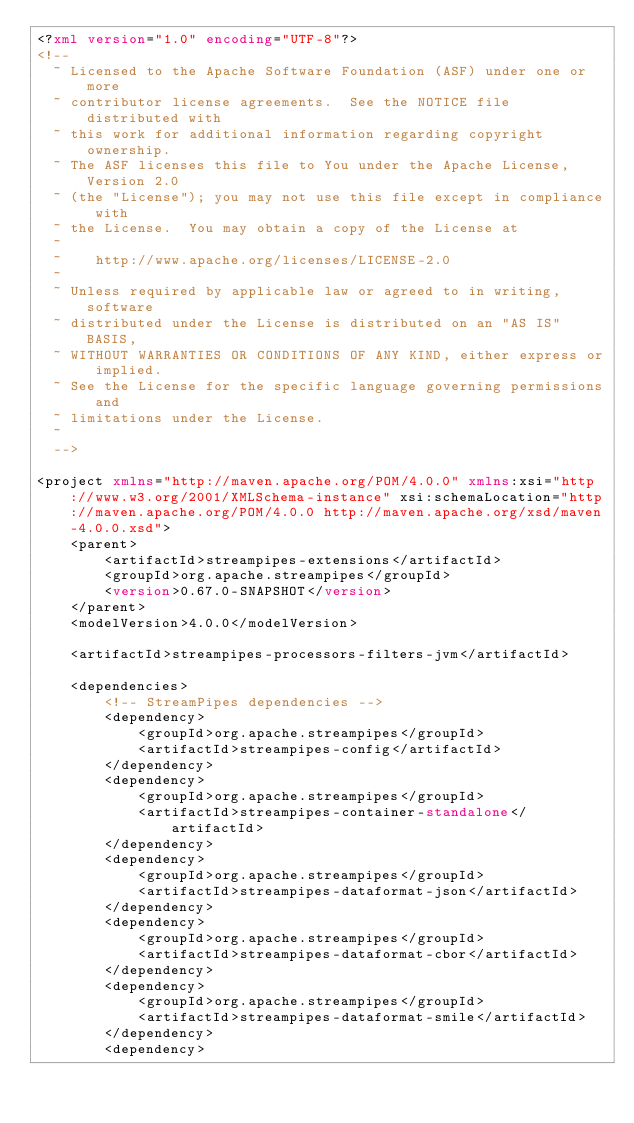<code> <loc_0><loc_0><loc_500><loc_500><_XML_><?xml version="1.0" encoding="UTF-8"?>
<!--
  ~ Licensed to the Apache Software Foundation (ASF) under one or more
  ~ contributor license agreements.  See the NOTICE file distributed with
  ~ this work for additional information regarding copyright ownership.
  ~ The ASF licenses this file to You under the Apache License, Version 2.0
  ~ (the "License"); you may not use this file except in compliance with
  ~ the License.  You may obtain a copy of the License at
  ~
  ~    http://www.apache.org/licenses/LICENSE-2.0
  ~
  ~ Unless required by applicable law or agreed to in writing, software
  ~ distributed under the License is distributed on an "AS IS" BASIS,
  ~ WITHOUT WARRANTIES OR CONDITIONS OF ANY KIND, either express or implied.
  ~ See the License for the specific language governing permissions and
  ~ limitations under the License.
  ~
  -->

<project xmlns="http://maven.apache.org/POM/4.0.0" xmlns:xsi="http://www.w3.org/2001/XMLSchema-instance" xsi:schemaLocation="http://maven.apache.org/POM/4.0.0 http://maven.apache.org/xsd/maven-4.0.0.xsd">
    <parent>
        <artifactId>streampipes-extensions</artifactId>
        <groupId>org.apache.streampipes</groupId>
        <version>0.67.0-SNAPSHOT</version>
    </parent>
    <modelVersion>4.0.0</modelVersion>

    <artifactId>streampipes-processors-filters-jvm</artifactId>

    <dependencies>
        <!-- StreamPipes dependencies -->
        <dependency>
            <groupId>org.apache.streampipes</groupId>
            <artifactId>streampipes-config</artifactId>
        </dependency>
        <dependency>
            <groupId>org.apache.streampipes</groupId>
            <artifactId>streampipes-container-standalone</artifactId>
        </dependency>
        <dependency>
            <groupId>org.apache.streampipes</groupId>
            <artifactId>streampipes-dataformat-json</artifactId>
        </dependency>
        <dependency>
            <groupId>org.apache.streampipes</groupId>
            <artifactId>streampipes-dataformat-cbor</artifactId>
        </dependency>
        <dependency>
            <groupId>org.apache.streampipes</groupId>
            <artifactId>streampipes-dataformat-smile</artifactId>
        </dependency>
        <dependency></code> 